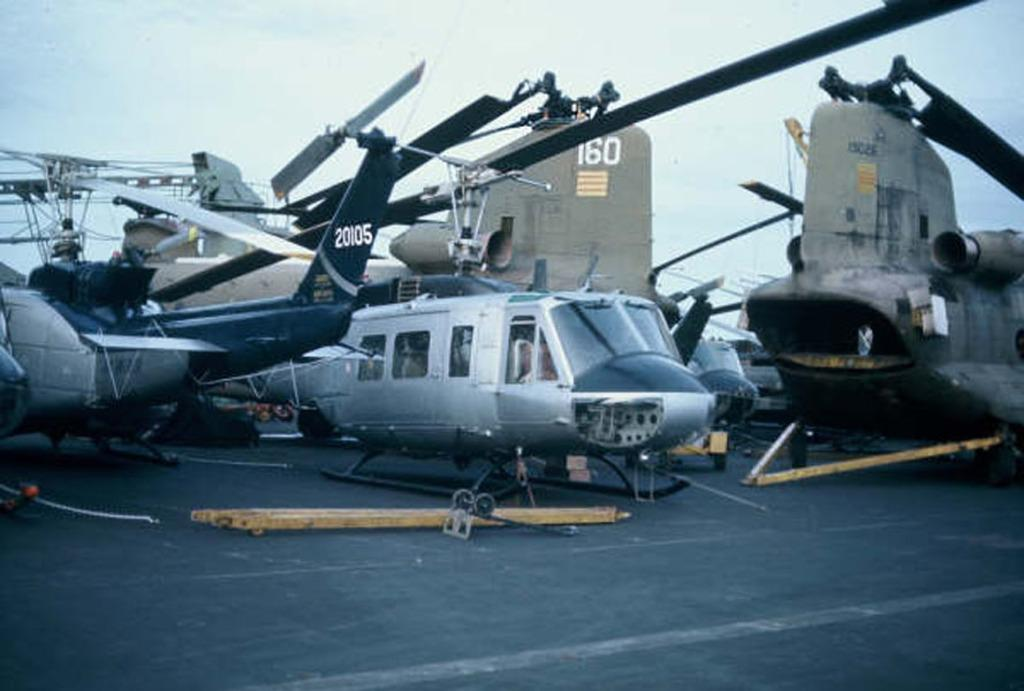<image>
Share a concise interpretation of the image provided. Several helicopters with tail number 20105 are parked on the deck of an aircraft carrier. 